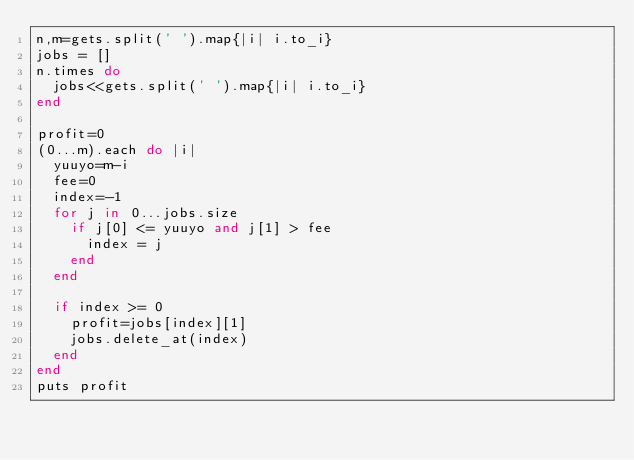Convert code to text. <code><loc_0><loc_0><loc_500><loc_500><_Ruby_>n,m=gets.split(' ').map{|i| i.to_i}
jobs = []
n.times do 
  jobs<<gets.split(' ').map{|i| i.to_i}
end

profit=0
(0...m).each do |i|
  yuuyo=m-i
  fee=0
  index=-1
  for j in 0...jobs.size
    if j[0] <= yuuyo and j[1] > fee
      index = j
    end
  end
  
  if index >= 0
    profit=jobs[index][1]
    jobs.delete_at(index)
  end
end
puts profit</code> 